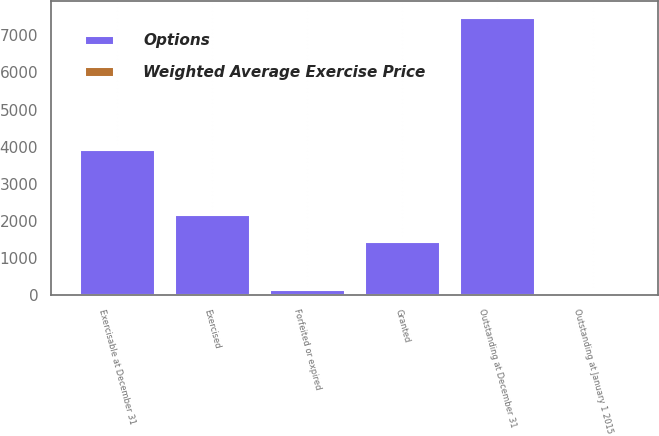Convert chart. <chart><loc_0><loc_0><loc_500><loc_500><stacked_bar_chart><ecel><fcel>Outstanding at January 1 2015<fcel>Granted<fcel>Exercised<fcel>Forfeited or expired<fcel>Outstanding at December 31<fcel>Exercisable at December 31<nl><fcel>Options<fcel>54.45<fcel>1455<fcel>2170<fcel>156<fcel>7507<fcel>3940<nl><fcel>Weighted Average Exercise Price<fcel>37.22<fcel>54.45<fcel>36.26<fcel>38.98<fcel>40.8<fcel>36.44<nl></chart> 